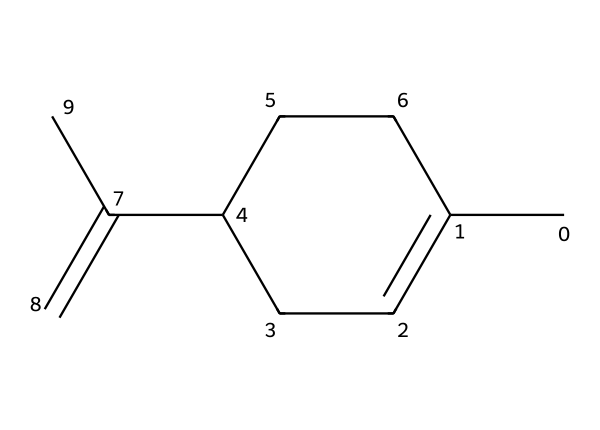How many carbon atoms are in limonene? By analyzing the SMILES representation, we can count the number of carbon atoms represented by 'C'. In this structure, there are 10 carbon atoms connected in various arrangements.
Answer: ten What is the molecular formula of limonene? The molecular formula can be deduced by counting the carbon and hydrogen atoms. With 10 carbon atoms and 16 hydrogen atoms derived from the structure, the resulting molecular formula is C10H16.
Answer: C10H16 What type of bonds are present in limonene? The structure includes single bonds and at least one double bond (indicated by the '=' sign in the SMILES). The presence of a double bond contributes to its reactivity.
Answer: single and double bonds Is limonene a cyclic compound? The chemical structure shows a ring formation (indicated by 'C1=CCC' and the connected atoms), which indicates that limonene is indeed a cyclic compound due to its closed-loop structure.
Answer: yes How many rings are present in the structure of limonene? By examining the structural representation, we see that there is only one complete ring structure (C1), thus it is a monocyclic compound.
Answer: one Does limonene belong to the class of terpenes? Limonene is classified as a terpene because it is derived from plants and is characterized by its specific carbon backbone structure typical of terpenes.
Answer: yes What functional group is evident in limonene? In the SMILES structure, the presence of a double bond indicates that limonene has a carbon-carbon double bond (alkene), a characteristic feature of many terpenes.
Answer: alkene 